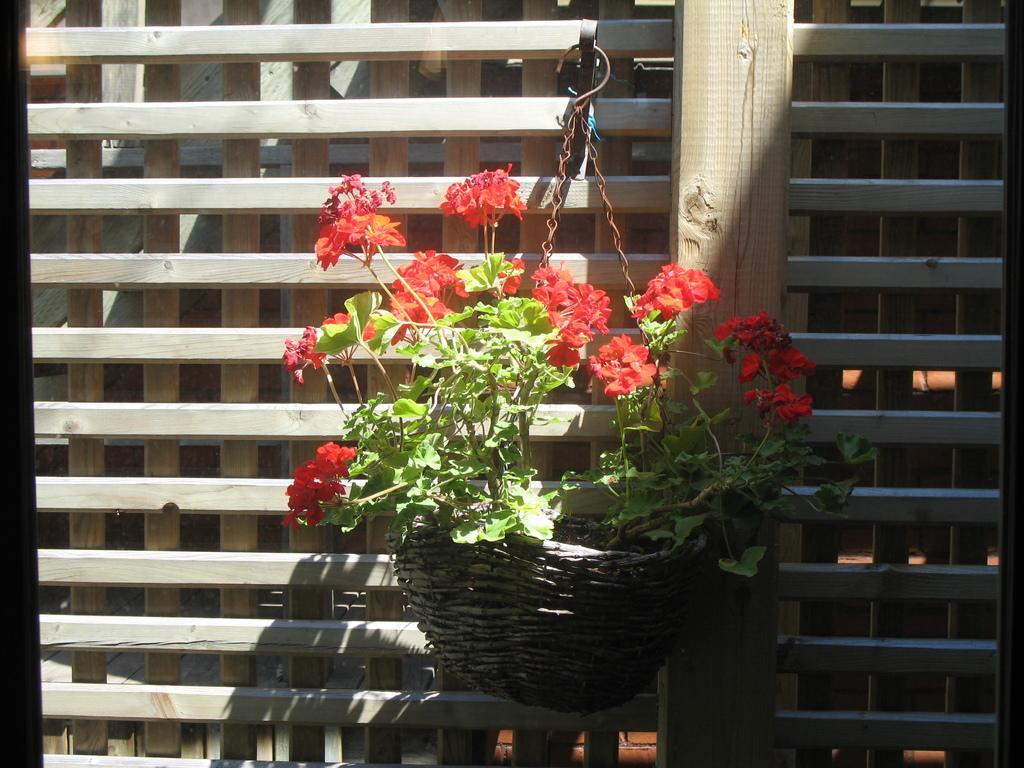Describe this image in one or two sentences. In the picture we can see a wooden plank wall with a hanger and some plants hanged with a bowl and to the plant we can see some flowers which are red in color. 